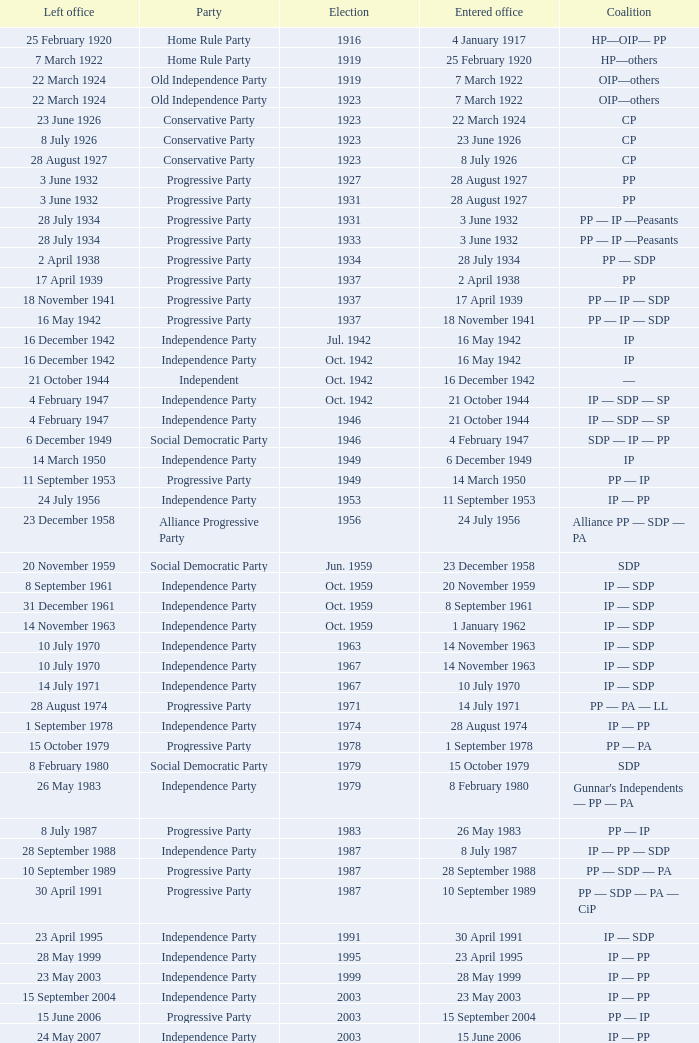When did the party elected in jun. 1959 enter office? 23 December 1958. Would you be able to parse every entry in this table? {'header': ['Left office', 'Party', 'Election', 'Entered office', 'Coalition'], 'rows': [['25 February 1920', 'Home Rule Party', '1916', '4 January 1917', 'HP—OIP— PP'], ['7 March 1922', 'Home Rule Party', '1919', '25 February 1920', 'HP—others'], ['22 March 1924', 'Old Independence Party', '1919', '7 March 1922', 'OIP—others'], ['22 March 1924', 'Old Independence Party', '1923', '7 March 1922', 'OIP—others'], ['23 June 1926', 'Conservative Party', '1923', '22 March 1924', 'CP'], ['8 July 1926', 'Conservative Party', '1923', '23 June 1926', 'CP'], ['28 August 1927', 'Conservative Party', '1923', '8 July 1926', 'CP'], ['3 June 1932', 'Progressive Party', '1927', '28 August 1927', 'PP'], ['3 June 1932', 'Progressive Party', '1931', '28 August 1927', 'PP'], ['28 July 1934', 'Progressive Party', '1931', '3 June 1932', 'PP — IP —Peasants'], ['28 July 1934', 'Progressive Party', '1933', '3 June 1932', 'PP — IP —Peasants'], ['2 April 1938', 'Progressive Party', '1934', '28 July 1934', 'PP — SDP'], ['17 April 1939', 'Progressive Party', '1937', '2 April 1938', 'PP'], ['18 November 1941', 'Progressive Party', '1937', '17 April 1939', 'PP — IP — SDP'], ['16 May 1942', 'Progressive Party', '1937', '18 November 1941', 'PP — IP — SDP'], ['16 December 1942', 'Independence Party', 'Jul. 1942', '16 May 1942', 'IP'], ['16 December 1942', 'Independence Party', 'Oct. 1942', '16 May 1942', 'IP'], ['21 October 1944', 'Independent', 'Oct. 1942', '16 December 1942', '—'], ['4 February 1947', 'Independence Party', 'Oct. 1942', '21 October 1944', 'IP — SDP — SP'], ['4 February 1947', 'Independence Party', '1946', '21 October 1944', 'IP — SDP — SP'], ['6 December 1949', 'Social Democratic Party', '1946', '4 February 1947', 'SDP — IP — PP'], ['14 March 1950', 'Independence Party', '1949', '6 December 1949', 'IP'], ['11 September 1953', 'Progressive Party', '1949', '14 March 1950', 'PP — IP'], ['24 July 1956', 'Independence Party', '1953', '11 September 1953', 'IP — PP'], ['23 December 1958', 'Alliance Progressive Party', '1956', '24 July 1956', 'Alliance PP — SDP — PA'], ['20 November 1959', 'Social Democratic Party', 'Jun. 1959', '23 December 1958', 'SDP'], ['8 September 1961', 'Independence Party', 'Oct. 1959', '20 November 1959', 'IP — SDP'], ['31 December 1961', 'Independence Party', 'Oct. 1959', '8 September 1961', 'IP — SDP'], ['14 November 1963', 'Independence Party', 'Oct. 1959', '1 January 1962', 'IP — SDP'], ['10 July 1970', 'Independence Party', '1963', '14 November 1963', 'IP — SDP'], ['10 July 1970', 'Independence Party', '1967', '14 November 1963', 'IP — SDP'], ['14 July 1971', 'Independence Party', '1967', '10 July 1970', 'IP — SDP'], ['28 August 1974', 'Progressive Party', '1971', '14 July 1971', 'PP — PA — LL'], ['1 September 1978', 'Independence Party', '1974', '28 August 1974', 'IP — PP'], ['15 October 1979', 'Progressive Party', '1978', '1 September 1978', 'PP — PA'], ['8 February 1980', 'Social Democratic Party', '1979', '15 October 1979', 'SDP'], ['26 May 1983', 'Independence Party', '1979', '8 February 1980', "Gunnar's Independents — PP — PA"], ['8 July 1987', 'Progressive Party', '1983', '26 May 1983', 'PP — IP'], ['28 September 1988', 'Independence Party', '1987', '8 July 1987', 'IP — PP — SDP'], ['10 September 1989', 'Progressive Party', '1987', '28 September 1988', 'PP — SDP — PA'], ['30 April 1991', 'Progressive Party', '1987', '10 September 1989', 'PP — SDP — PA — CiP'], ['23 April 1995', 'Independence Party', '1991', '30 April 1991', 'IP — SDP'], ['28 May 1999', 'Independence Party', '1995', '23 April 1995', 'IP — PP'], ['23 May 2003', 'Independence Party', '1999', '28 May 1999', 'IP — PP'], ['15 September 2004', 'Independence Party', '2003', '23 May 2003', 'IP — PP'], ['15 June 2006', 'Progressive Party', '2003', '15 September 2004', 'PP — IP'], ['24 May 2007', 'Independence Party', '2003', '15 June 2006', 'IP — PP'], ['1 February 2009', 'Independence Party', '2007', '24 May 2007', 'IP — SDA'], ['10 May 2009', 'Social Democratic Alliance', '2007', '1 February 2009', 'SDA — LGM'], ['23 May 2013', 'Social Democratic Alliance', '2009', '10 May 2009', 'SDA — LGM'], ['Incumbent', 'Progressive Party', '2013', '23 May 2013', 'PP — IP']]} 